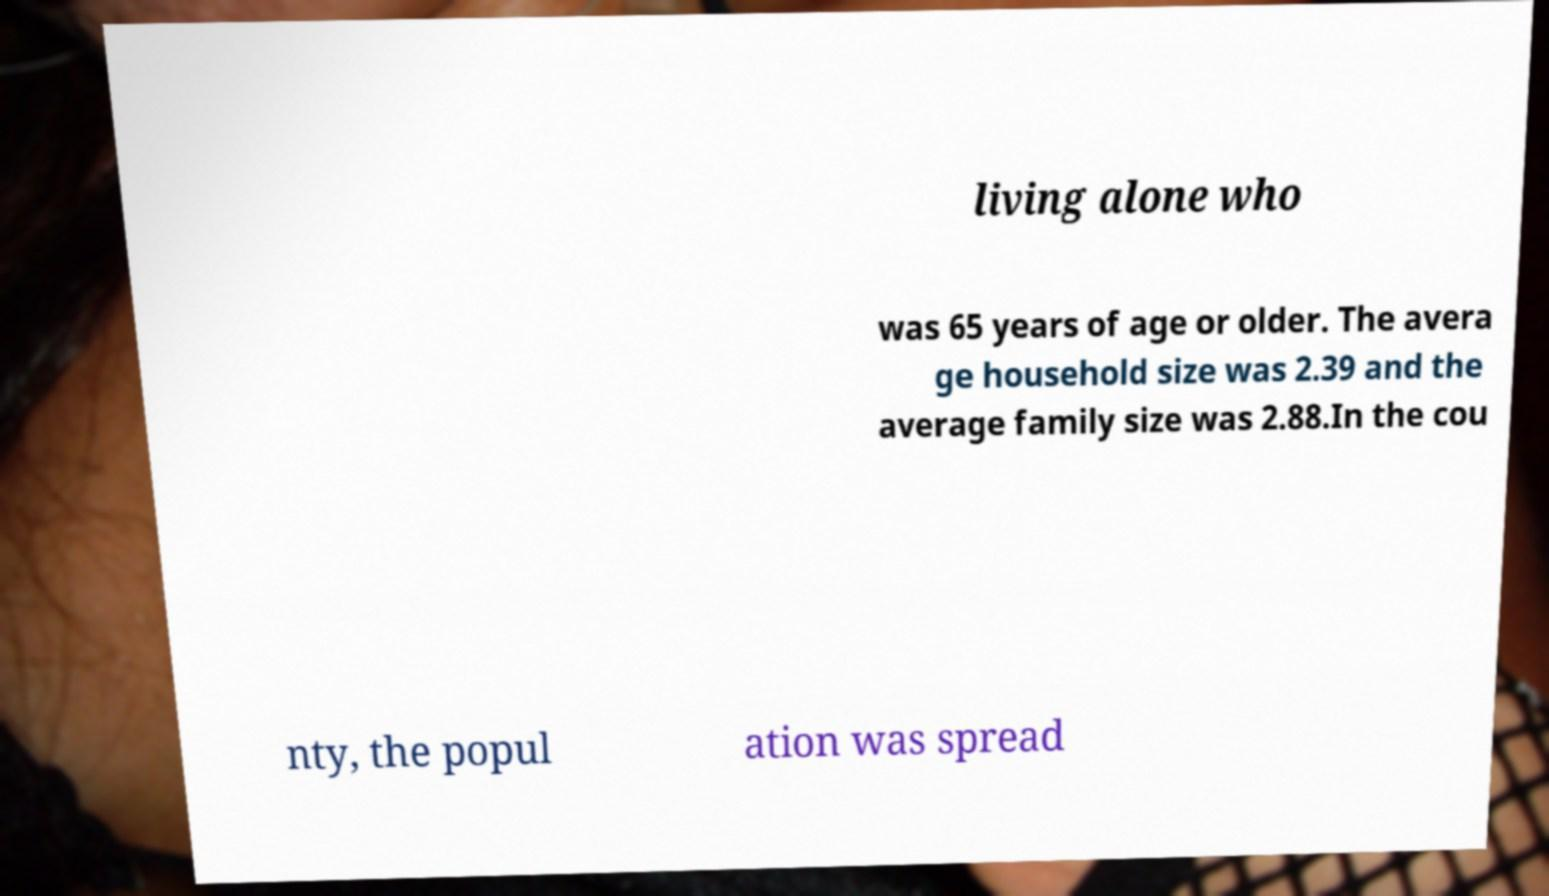Can you read and provide the text displayed in the image?This photo seems to have some interesting text. Can you extract and type it out for me? living alone who was 65 years of age or older. The avera ge household size was 2.39 and the average family size was 2.88.In the cou nty, the popul ation was spread 